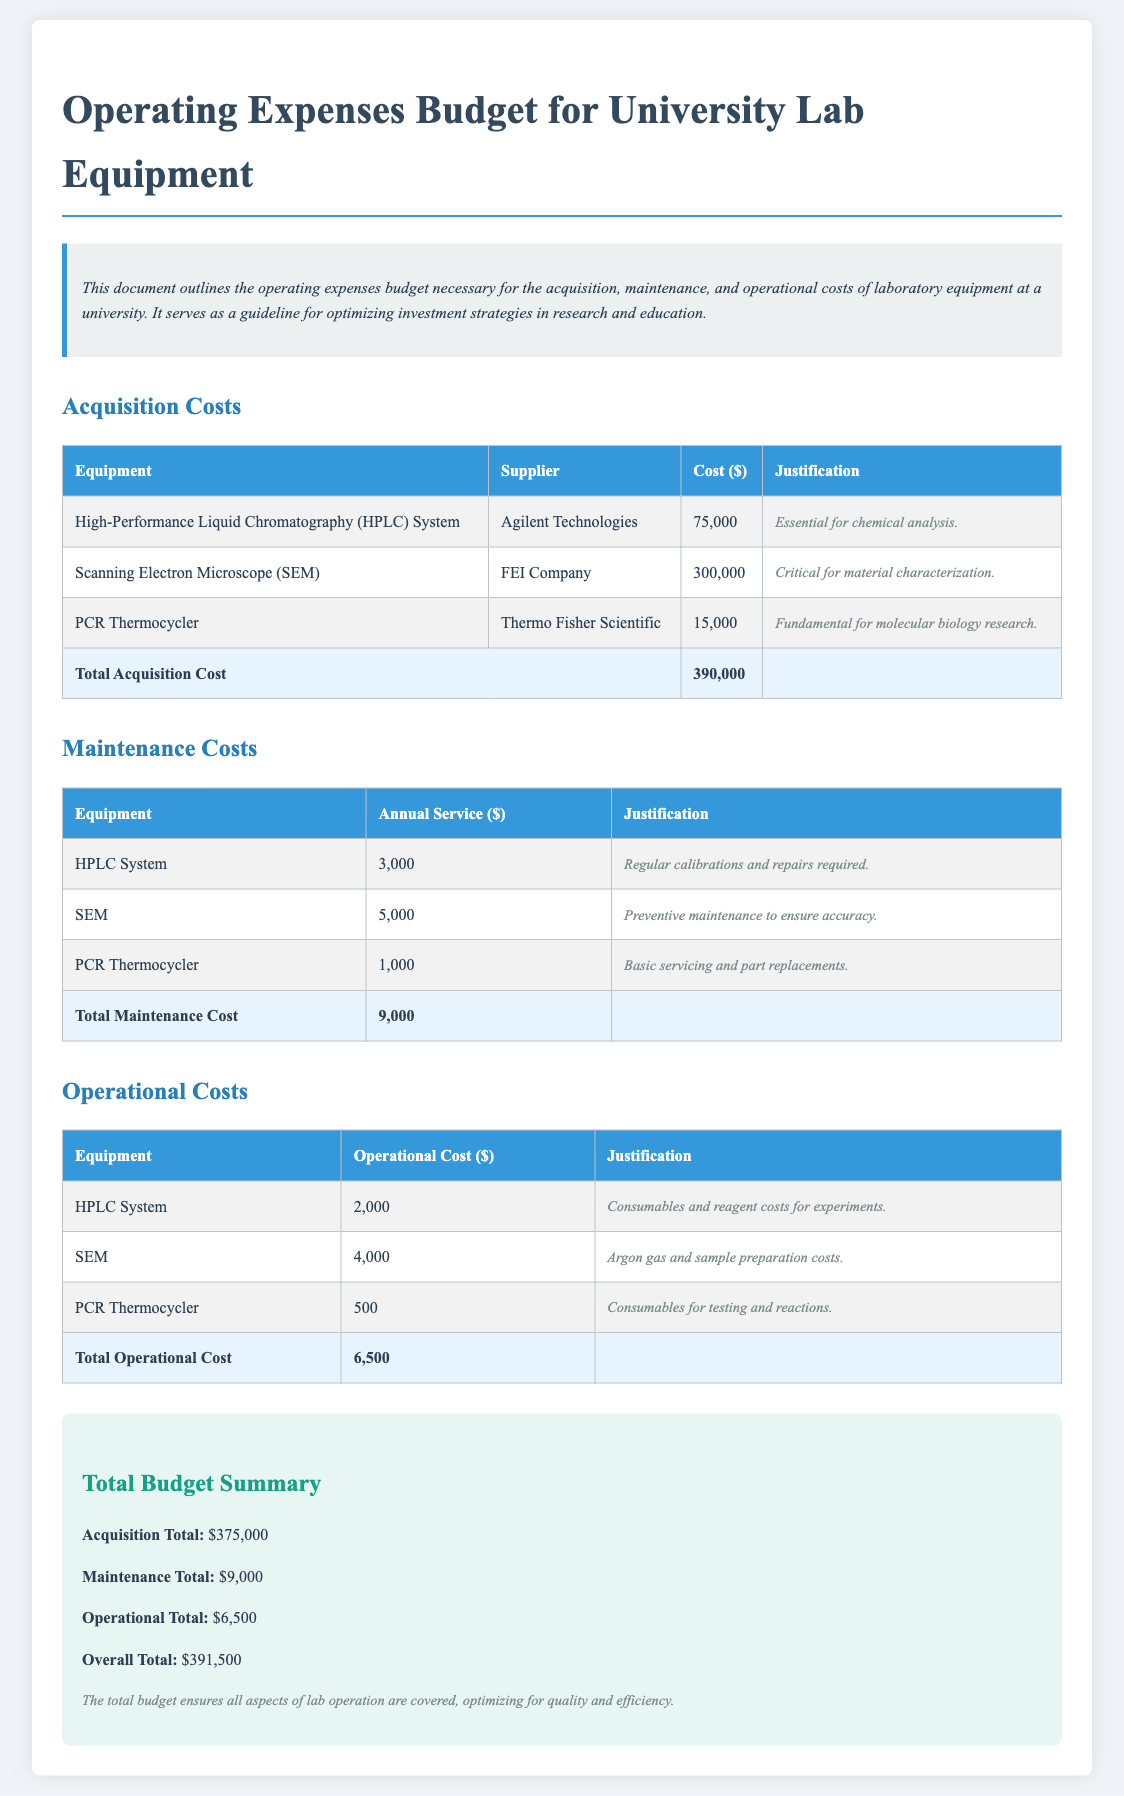What is the total acquisition cost? The total acquisition cost is presented at the end of the acquisition section, which sums the costs of all listed equipment.
Answer: 390,000 Which company supplies the Scanning Electron Microscope? The document specifies the supplier for the Scanning Electron Microscope in the acquisition costs table.
Answer: FEI Company What is the annual service cost for the HPLC System? The annual service cost for the HPLC System is listed in the maintenance costs table.
Answer: 3,000 What is the overall total budget? The overall total budget is provided in the summary section, which aggregates acquisition, maintenance, and operational costs.
Answer: 391,500 What are the operational costs for the PCR Thermocycler? The operational costs for the PCR Thermocycler are detailed in the operational costs table.
Answer: 500 Which equipment requires argon gas in its operational costs? The operational costs table indicates the equipment associated with argon gas.
Answer: Scanning Electron Microscope Why is the HPLC System essential? The justification for the HPLC System is provided alongside its acquisition cost in the document.
Answer: Essential for chemical analysis How much is allocated for maintenance costs in total? The total maintenance costs are summarized at the end of the maintenance costs section in the document.
Answer: 9,000 